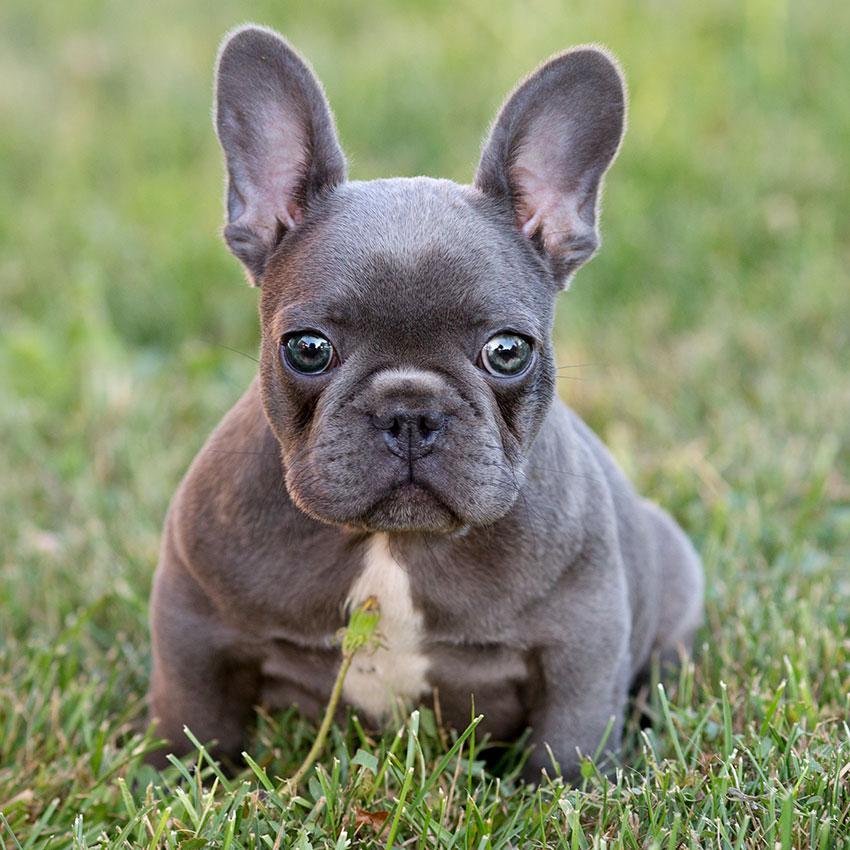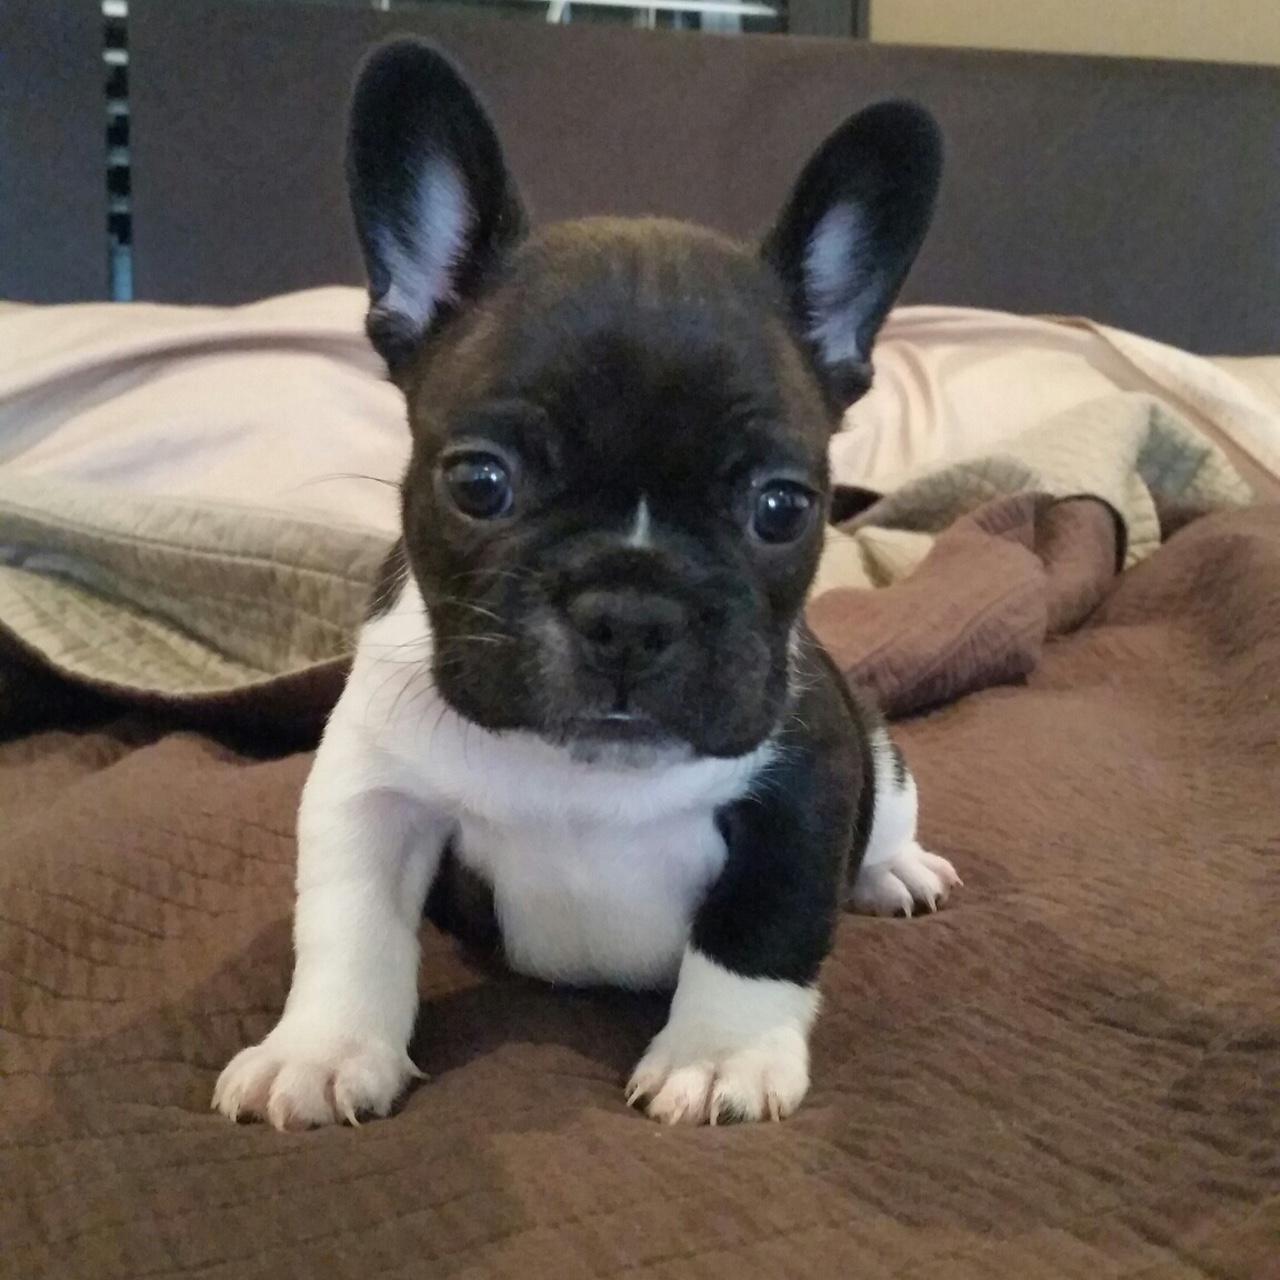The first image is the image on the left, the second image is the image on the right. For the images shown, is this caption "One of the dogs is biting a stuffed animal." true? Answer yes or no. No. The first image is the image on the left, the second image is the image on the right. Considering the images on both sides, is "In one of the image the dog is on the grass." valid? Answer yes or no. Yes. 